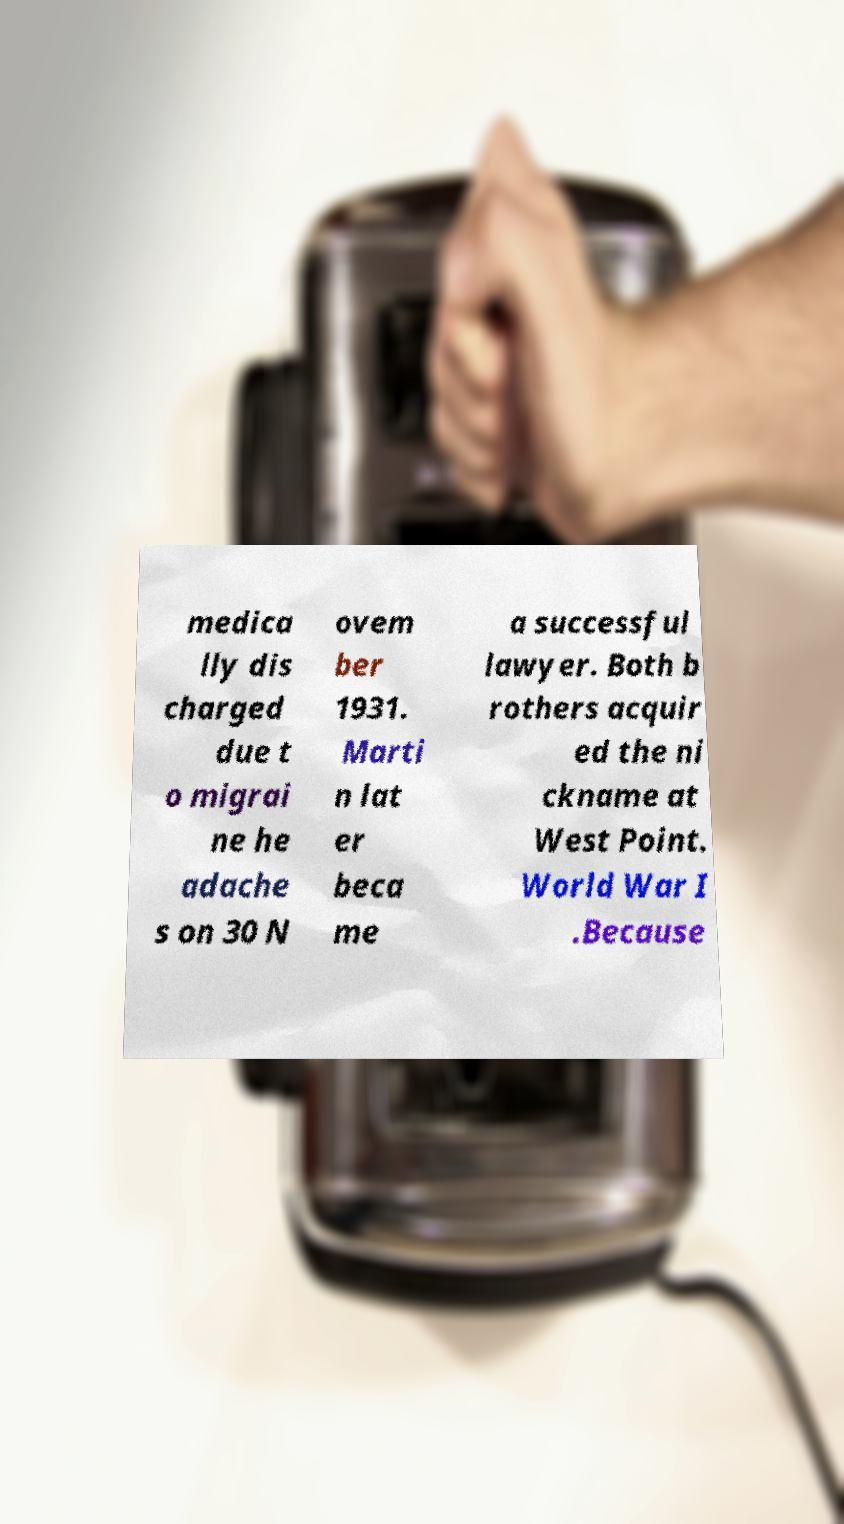Could you extract and type out the text from this image? medica lly dis charged due t o migrai ne he adache s on 30 N ovem ber 1931. Marti n lat er beca me a successful lawyer. Both b rothers acquir ed the ni ckname at West Point. World War I .Because 